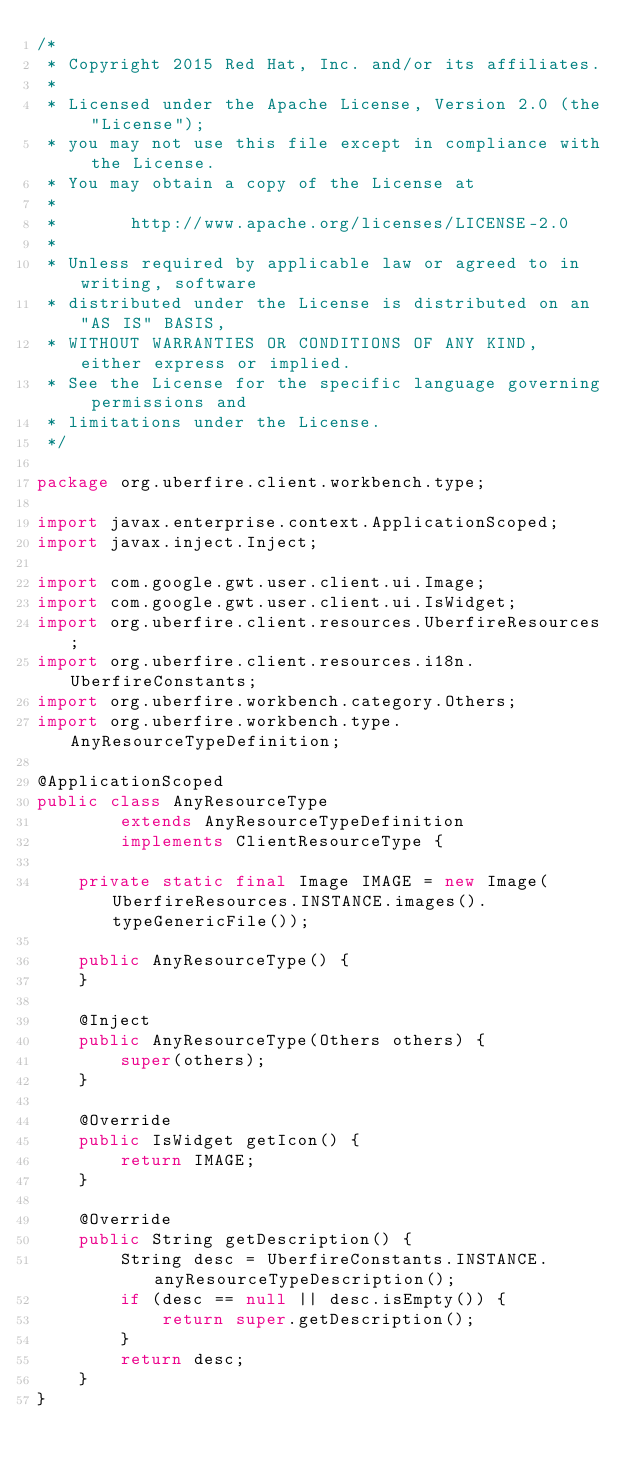<code> <loc_0><loc_0><loc_500><loc_500><_Java_>/*
 * Copyright 2015 Red Hat, Inc. and/or its affiliates.
 *
 * Licensed under the Apache License, Version 2.0 (the "License");
 * you may not use this file except in compliance with the License.
 * You may obtain a copy of the License at
 *
 *       http://www.apache.org/licenses/LICENSE-2.0
 *
 * Unless required by applicable law or agreed to in writing, software
 * distributed under the License is distributed on an "AS IS" BASIS,
 * WITHOUT WARRANTIES OR CONDITIONS OF ANY KIND, either express or implied.
 * See the License for the specific language governing permissions and
 * limitations under the License.
 */

package org.uberfire.client.workbench.type;

import javax.enterprise.context.ApplicationScoped;
import javax.inject.Inject;

import com.google.gwt.user.client.ui.Image;
import com.google.gwt.user.client.ui.IsWidget;
import org.uberfire.client.resources.UberfireResources;
import org.uberfire.client.resources.i18n.UberfireConstants;
import org.uberfire.workbench.category.Others;
import org.uberfire.workbench.type.AnyResourceTypeDefinition;

@ApplicationScoped
public class AnyResourceType
        extends AnyResourceTypeDefinition
        implements ClientResourceType {

    private static final Image IMAGE = new Image(UberfireResources.INSTANCE.images().typeGenericFile());

    public AnyResourceType() {
    }

    @Inject
    public AnyResourceType(Others others) {
        super(others);
    }

    @Override
    public IsWidget getIcon() {
        return IMAGE;
    }

    @Override
    public String getDescription() {
        String desc = UberfireConstants.INSTANCE.anyResourceTypeDescription();
        if (desc == null || desc.isEmpty()) {
            return super.getDescription();
        }
        return desc;
    }
}
</code> 